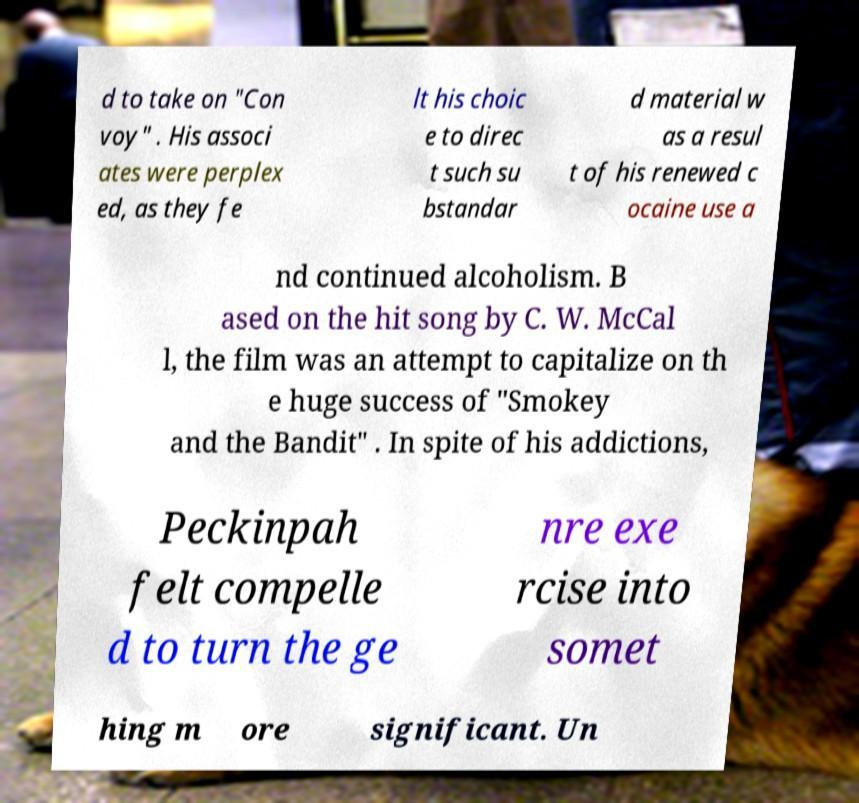Please read and relay the text visible in this image. What does it say? d to take on "Con voy" . His associ ates were perplex ed, as they fe lt his choic e to direc t such su bstandar d material w as a resul t of his renewed c ocaine use a nd continued alcoholism. B ased on the hit song by C. W. McCal l, the film was an attempt to capitalize on th e huge success of "Smokey and the Bandit" . In spite of his addictions, Peckinpah felt compelle d to turn the ge nre exe rcise into somet hing m ore significant. Un 